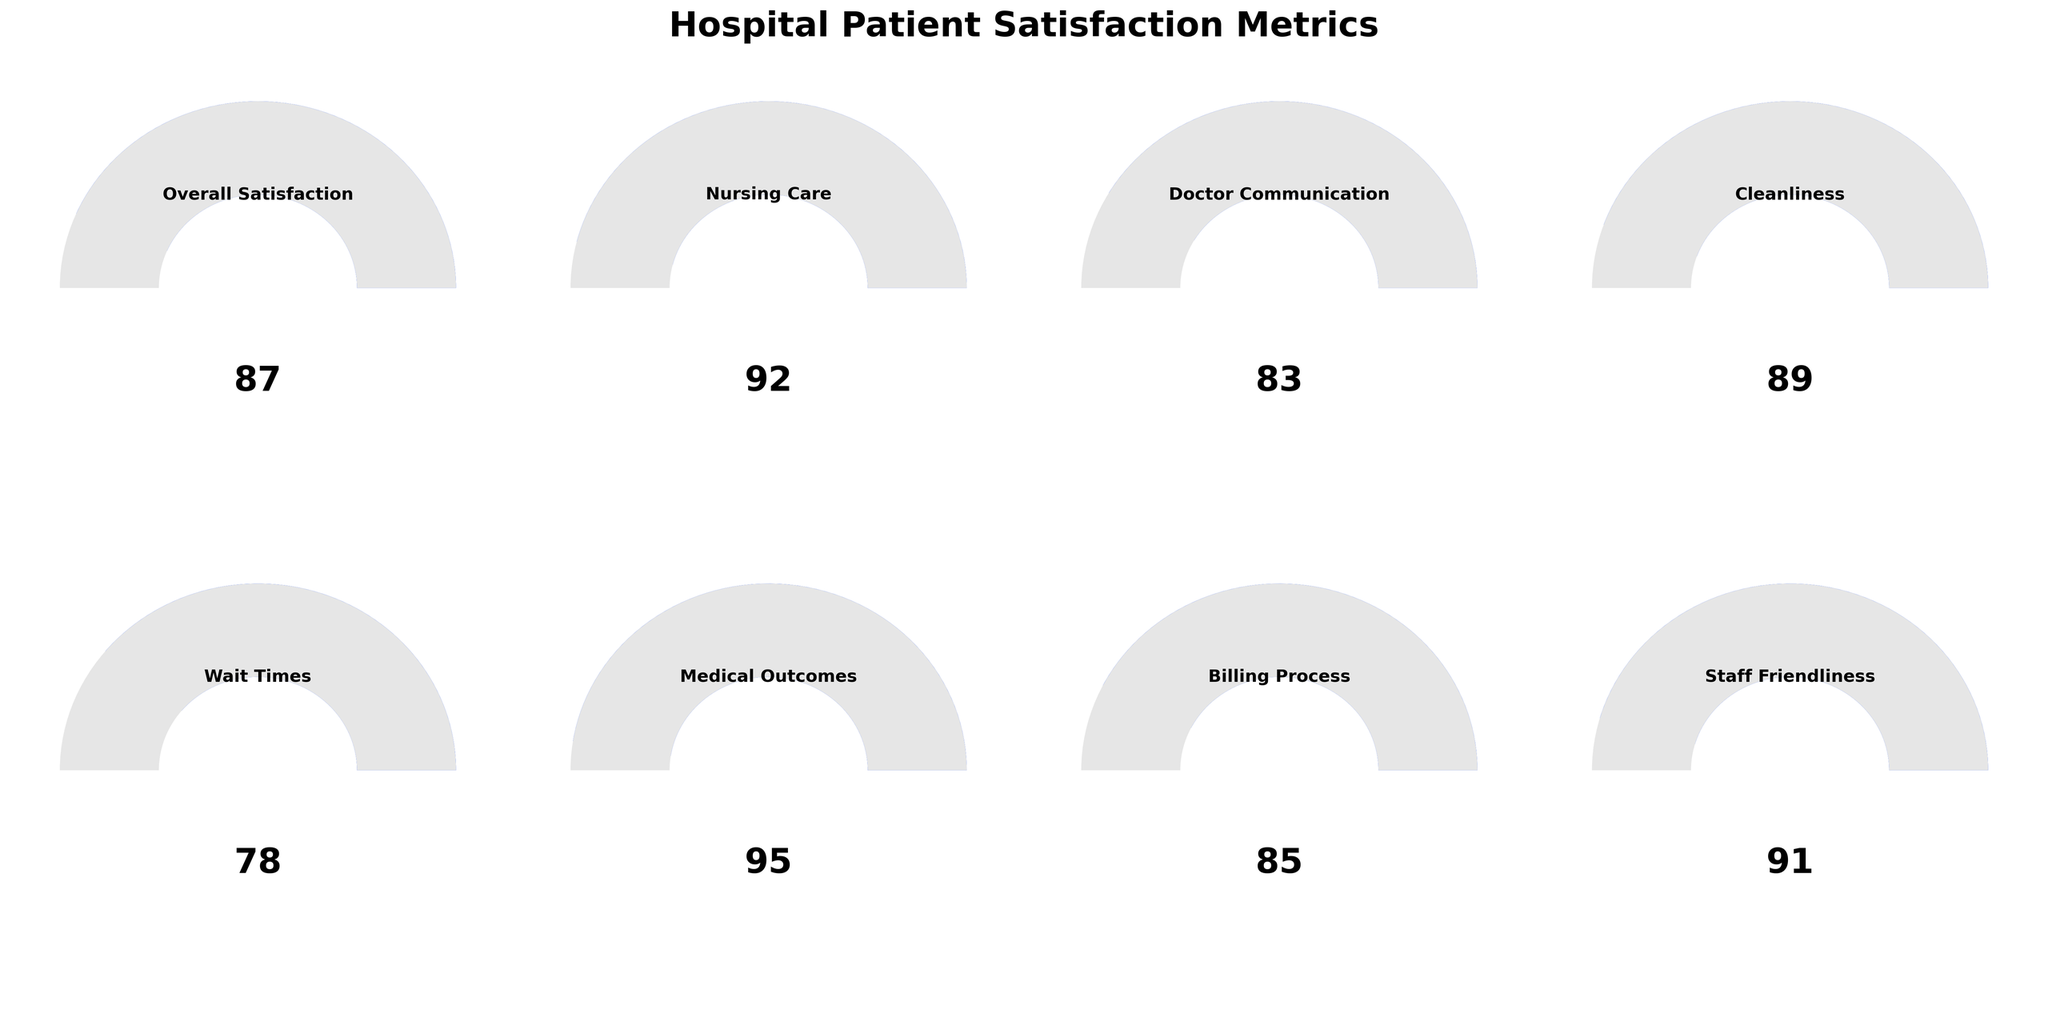What is the overall satisfaction score? The overall satisfaction score is directly indicated by the gauge chart labeled "Overall Satisfaction" with the score at the center.
Answer: 87 Which category has the highest satisfaction score? By scanning all the displayed categories, the one with the highest score is identified in the "Medical Outcomes" gauge chart.
Answer: Medical Outcomes What is the average satisfaction score across all categories? To find the average: add all scores (87 + 92 + 83 + 89 + 78 + 95 + 85 + 91) to get 700, then divide by the number of categories (8).
Answer: 87.5 Which category has the lowest satisfaction score? The lowest value on the gauge charts is seen in the "Wait Times" category, scoring 78.
Answer: Wait Times How does the satisfaction score for Nursing Care compare to that of Cleanliness? The Nursing Care category has a score of 92 and Cleanliness has a score of 89. Comparing both, Nursing Care has a higher score.
Answer: Nursing Care is higher What's the total satisfaction score if you sum Nursing Care and Staff Friendliness? Add the scores for Nursing Care (92) and Staff Friendliness (91) to get the total: 92 + 91 = 183.
Answer: 183 Between Doctor Communication and Billing Process, which one has a higher satisfaction score and by how much? Doctor Communication has a score of 83, and Billing Process has a score of 85. The difference is 85 - 83 = 2. Billing Process has the higher score.
Answer: Billing Process by 2 What is the difference between the highest and lowest satisfaction scores? The highest score is for Medical Outcomes (95) and the lowest is for Wait Times (78). The difference is calculated as 95 - 78 = 17.
Answer: 17 Which categories have satisfaction scores above 90? By reviewing each gauge chart, the categories with scores above 90 are Nursing Care (92), Medical Outcomes (95), and Staff Friendliness (91).
Answer: Nursing Care, Medical Outcomes, Staff Friendliness What is the satisfaction score for the Billing Process category? The score is directly readable from the gauge chart labeled "Billing Process" with the score at the center.
Answer: 85 